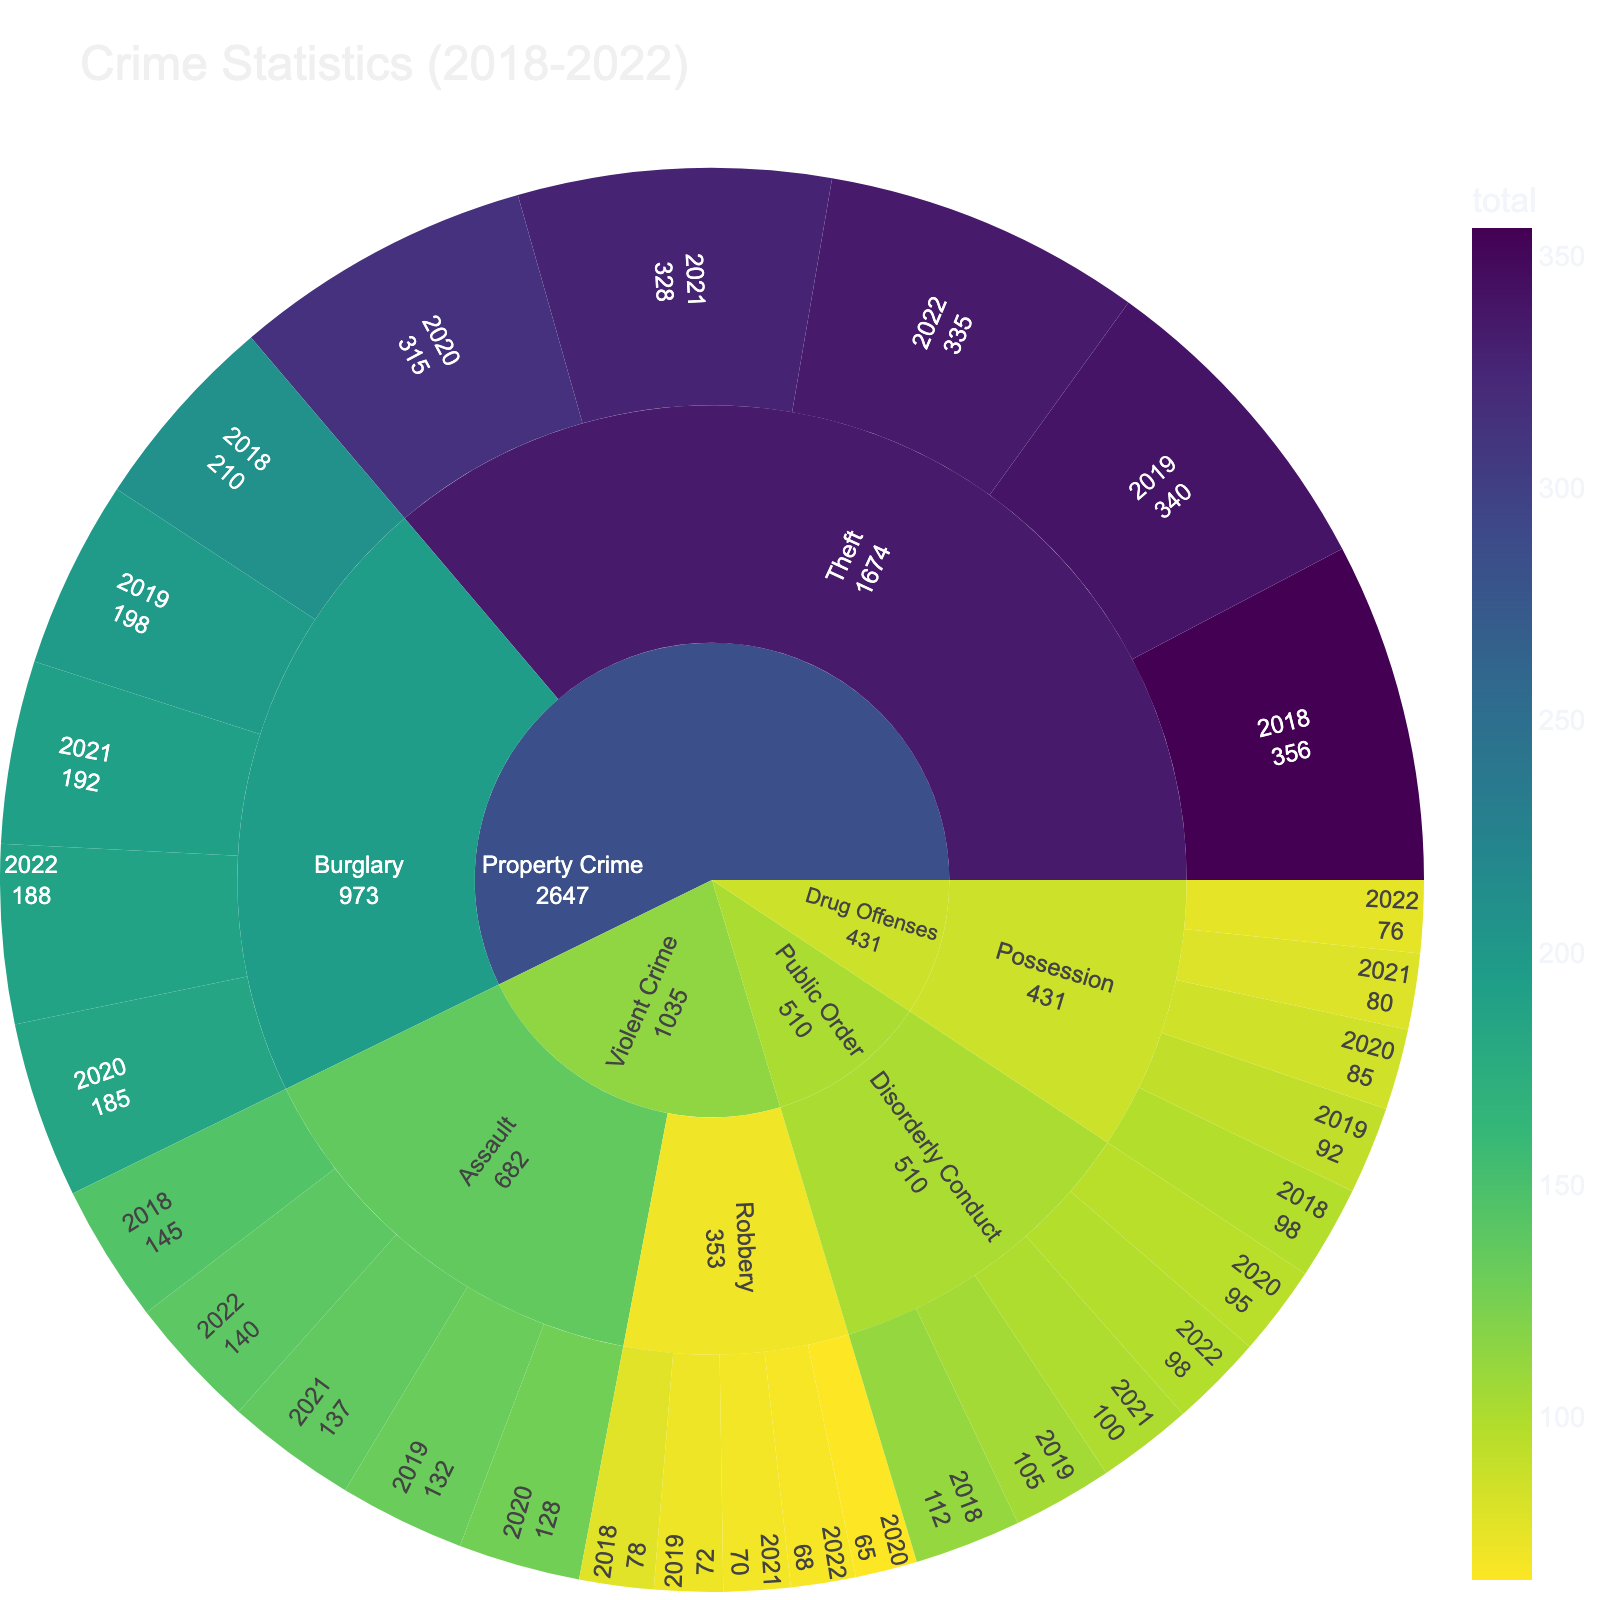How many different crime categories are there in the plot? The sunburst plot contains a hierarchical structure with crime categories as the top level; by looking at the number of top-level divisions, we can count them. There are 4 distinct sections indicating 4 different categories.
Answer: 4 Which year had the highest count of theft in property crime? In the sunburst plot, navigate to the 'Property Crime' section, then within that, find 'Theft,' and compare the counts for each year. The theft counts are 356, 340, 315, 328, and 335 for the years 2018, 2019, 2020, 2021, and 2022 respectively.
Answer: 2018 What is the difference in the number of burglary offenses between 2018 and 2022? Locate the 'Property Crime' category, then 'Burglary' subcategory, and find the counts for 2018 and 2022, which are 210 and 188 respectively. Subtract the 2022 count from the 2018 count.
Answer: 22 Which type of violent crime had a higher total count in 2020, assault or robbery? Within the 'Violent Crime' category, compare the counts for 'Assault' and 'Robbery' in 2020. Assault count is 128 and Robbery count is 65.
Answer: Assault What is the average count of possession offenses over the five years? In the 'Drug Offenses' category, find the 'Possession' subcategory, and sum the counts from 2018 to 2022 (98+92+85+80+76), then divide by 5. The total is 431.
Answer: 86.2 Which year shows the lowest count for disorderly conduct? In the 'Public Order' category, find the 'Disorderly Conduct' subcategory and compare counts for each year. The counts are 112, 105, 95, 100, and 98 for 2018 through 2022 respectively.
Answer: 2020 How does the count of robbery in 2019 compare to 2022? Within 'Violent Crime', compare 'Robbery' counts for 2019 and 2022. The counts are 72 and 68 respectively; 72 is greater than 68.
Answer: Higher in 2019 What is the total count of all drug offenses across the five years? In 'Drug Offenses', see 'Possession' counts from each year, and sum these counts (98+92+85+80+76).
Answer: 431 What's the difference in total count between theft (property crime) and disorderly conduct (public order) in 2022? Find total counts for 'Theft' under 'Property Crime' and 'Disorderly Conduct' under 'Public Order' for the year 2022, and subtract the smaller count from the larger. Theft has 335 and Disorderly Conduct has 98.
Answer: 237 Which specific crime type has shown a decreasing trend consistently over the five years? Examine each subcategory and compare counts over the years. 'Drug Offenses' category, 'Possession', shows a consistent decrease: 98, 92, 85, 80, 76.
Answer: Possession 